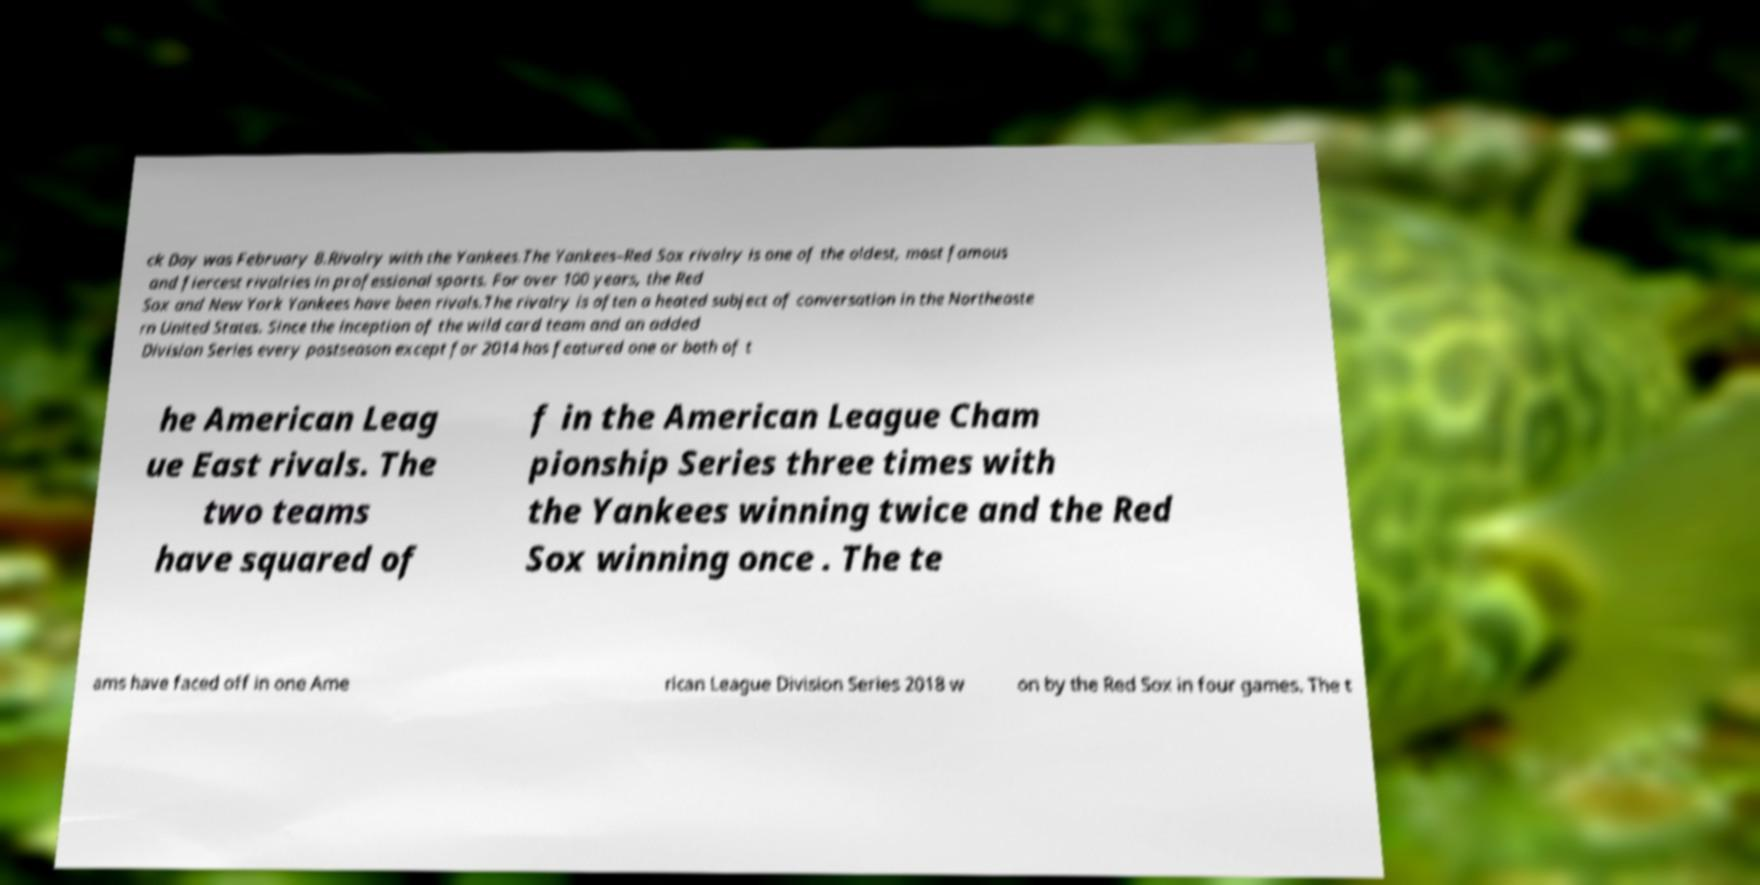Could you assist in decoding the text presented in this image and type it out clearly? ck Day was February 8.Rivalry with the Yankees.The Yankees–Red Sox rivalry is one of the oldest, most famous and fiercest rivalries in professional sports. For over 100 years, the Red Sox and New York Yankees have been rivals.The rivalry is often a heated subject of conversation in the Northeaste rn United States. Since the inception of the wild card team and an added Division Series every postseason except for 2014 has featured one or both of t he American Leag ue East rivals. The two teams have squared of f in the American League Cham pionship Series three times with the Yankees winning twice and the Red Sox winning once . The te ams have faced off in one Ame rican League Division Series 2018 w on by the Red Sox in four games. The t 